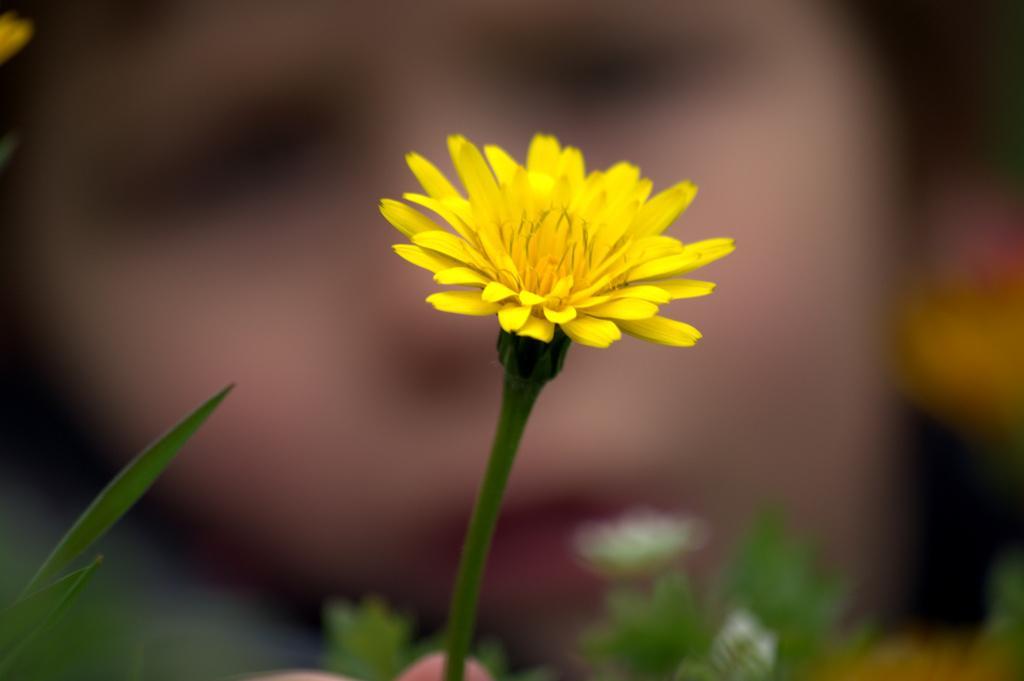Could you give a brief overview of what you see in this image? In this image, we can see a flower and stem. Here we can see leaves. Background we can see the blur view. 